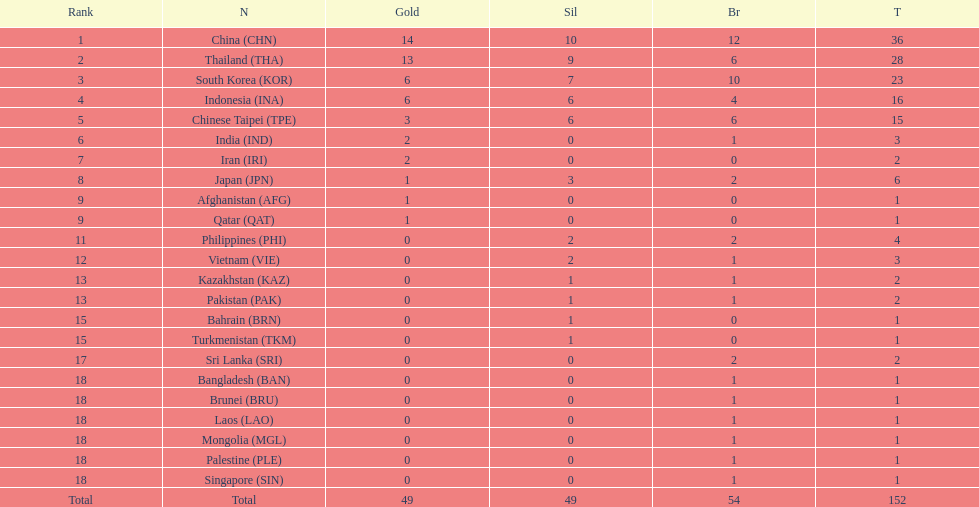Which countries won the same number of gold medals as japan? Afghanistan (AFG), Qatar (QAT). 